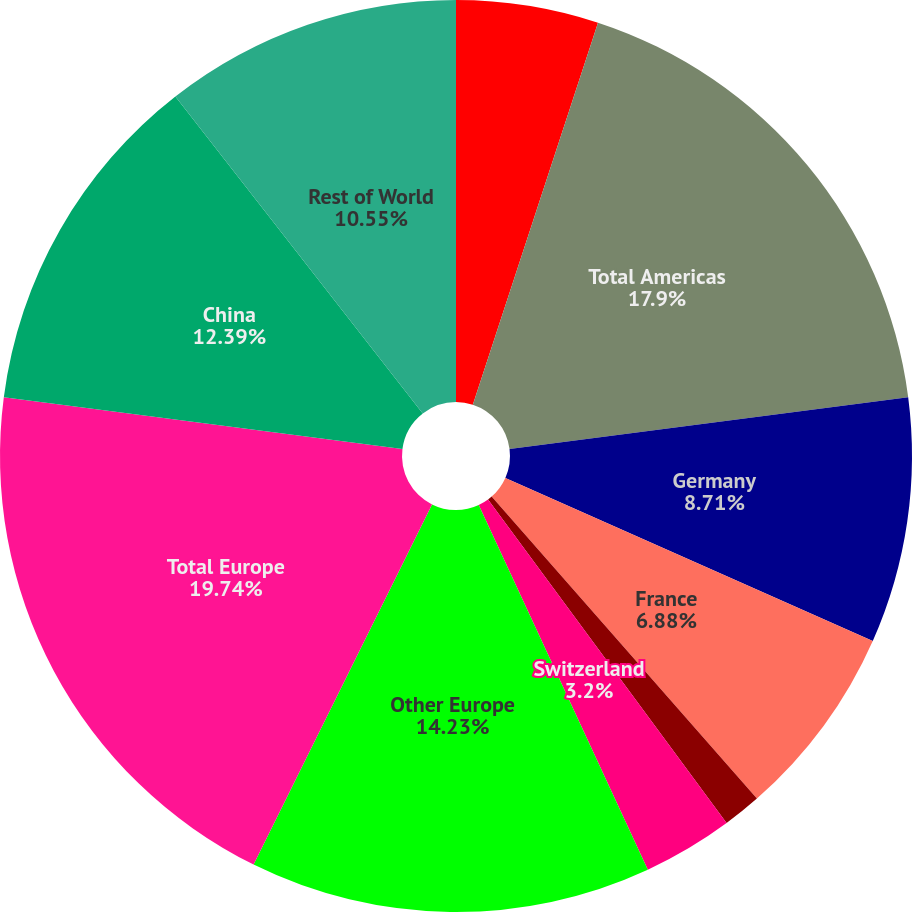Convert chart. <chart><loc_0><loc_0><loc_500><loc_500><pie_chart><fcel>Other Americas<fcel>Total Americas<fcel>Germany<fcel>France<fcel>United Kingdom<fcel>Switzerland<fcel>Other Europe<fcel>Total Europe<fcel>China<fcel>Rest of World<nl><fcel>5.04%<fcel>17.9%<fcel>8.71%<fcel>6.88%<fcel>1.36%<fcel>3.2%<fcel>14.23%<fcel>19.74%<fcel>12.39%<fcel>10.55%<nl></chart> 